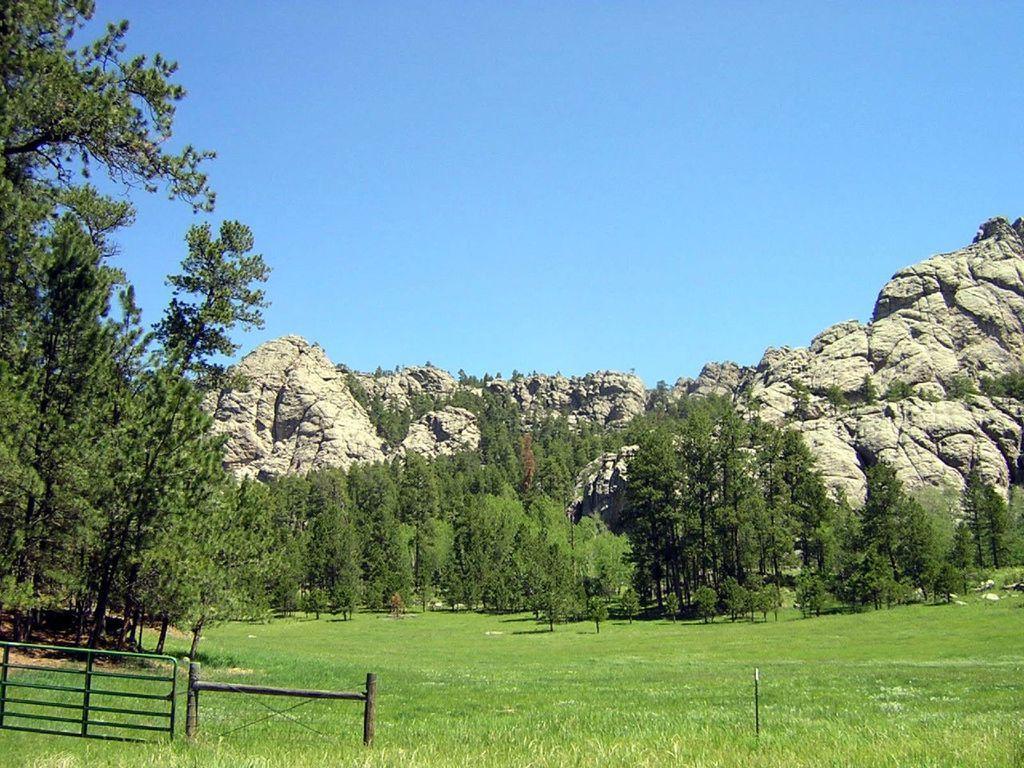Describe this image in one or two sentences. In the background of the image there are mountains. There are trees. At the bottom of the image there is grass. There is a fencing. 